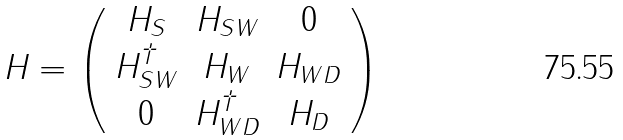Convert formula to latex. <formula><loc_0><loc_0><loc_500><loc_500>H = \left ( \begin{array} { c c c } H _ { S } & H _ { S W } & 0 \\ H _ { S W } ^ { \dag } & H _ { W } & H _ { W D } \\ 0 & H _ { W D } ^ { \dag } & H _ { D } \\ \end{array} \right )</formula> 